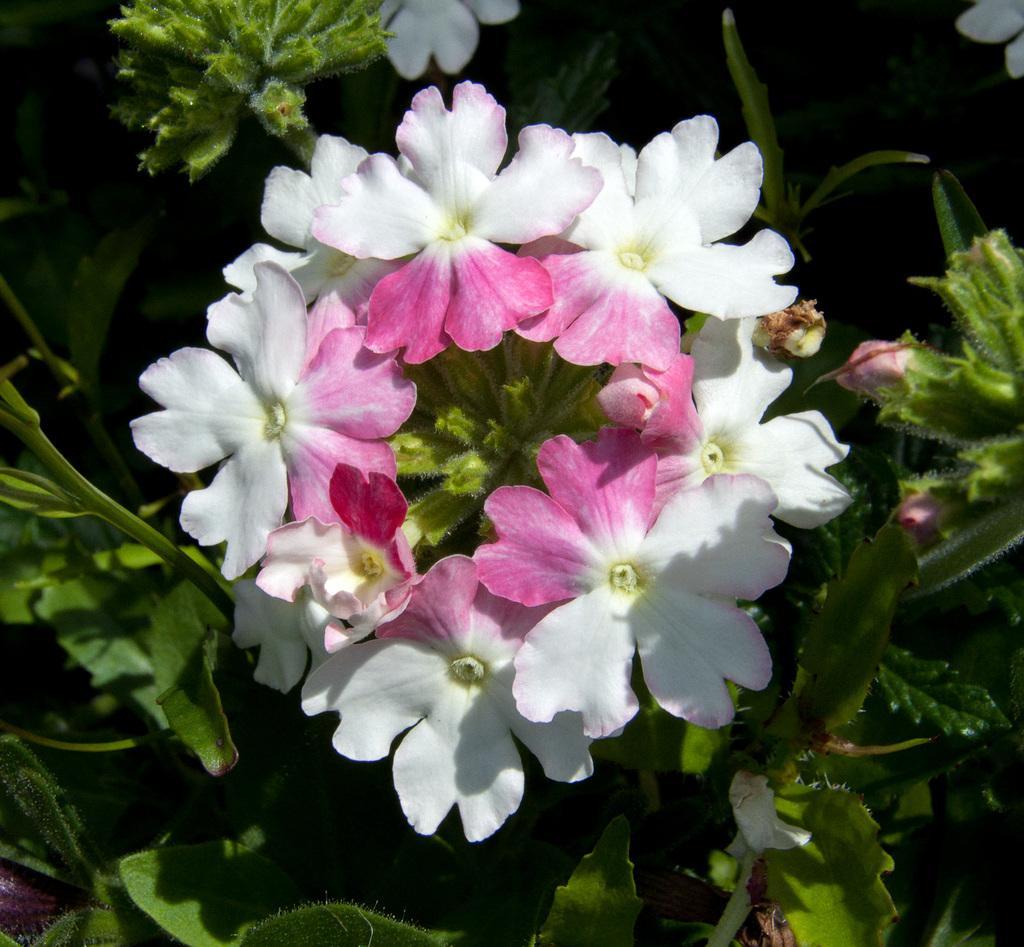In one or two sentences, can you explain what this image depicts? In the center of the image flowers are there. In the background of the image leaves are there. 